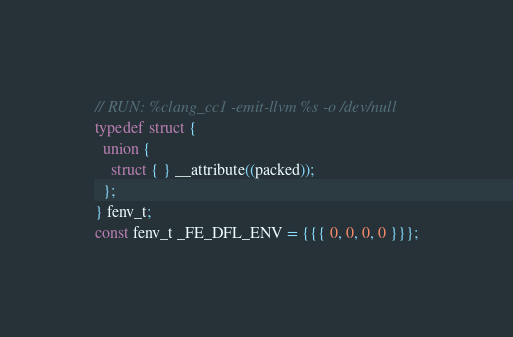Convert code to text. <code><loc_0><loc_0><loc_500><loc_500><_C_>// RUN: %clang_cc1 -emit-llvm %s -o /dev/null
typedef struct {
  union {
    struct { } __attribute((packed));
  };
} fenv_t;
const fenv_t _FE_DFL_ENV = {{{ 0, 0, 0, 0 }}};
</code> 